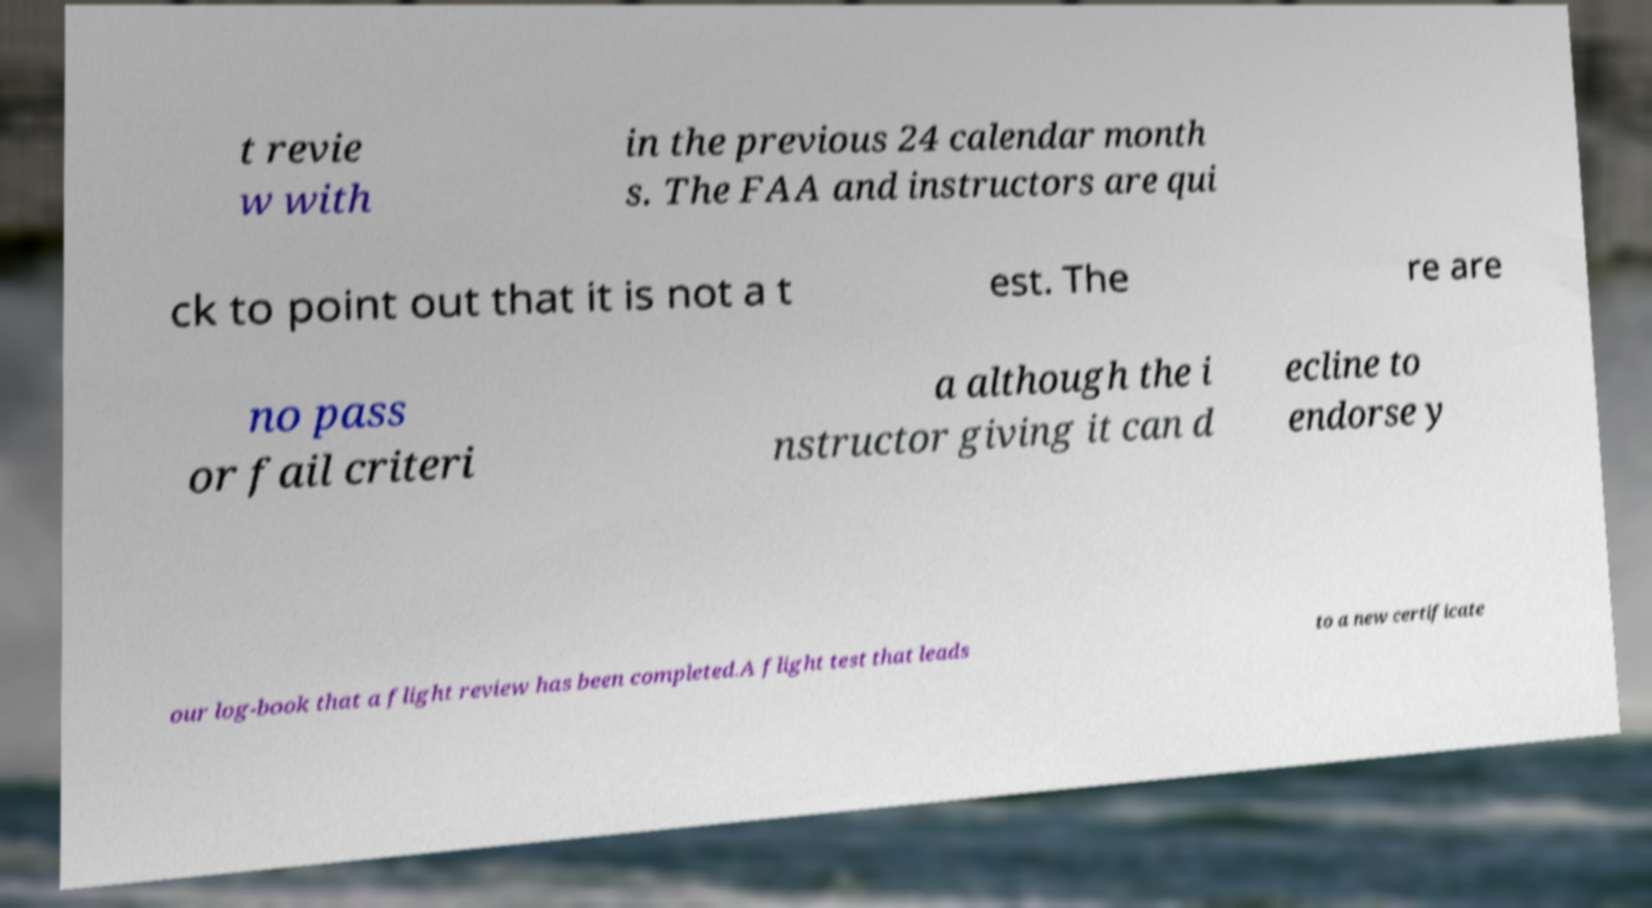Can you accurately transcribe the text from the provided image for me? t revie w with in the previous 24 calendar month s. The FAA and instructors are qui ck to point out that it is not a t est. The re are no pass or fail criteri a although the i nstructor giving it can d ecline to endorse y our log-book that a flight review has been completed.A flight test that leads to a new certificate 